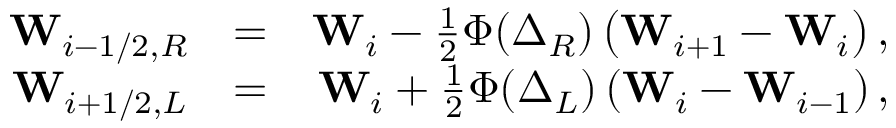<formula> <loc_0><loc_0><loc_500><loc_500>\begin{array} { r l r } { W _ { i - 1 / 2 , R } } & { = } & { W _ { i } - \frac { 1 } { 2 } \Phi ( \boldsymbol \Delta _ { R } ) \left ( W _ { i + 1 } - W _ { i } \right ) , } \\ { W _ { i + 1 / 2 , L } } & { = } & { W _ { i } + \frac { 1 } { 2 } \Phi ( \boldsymbol \Delta _ { L } ) \left ( W _ { i } - W _ { i - 1 } \right ) , } \end{array}</formula> 